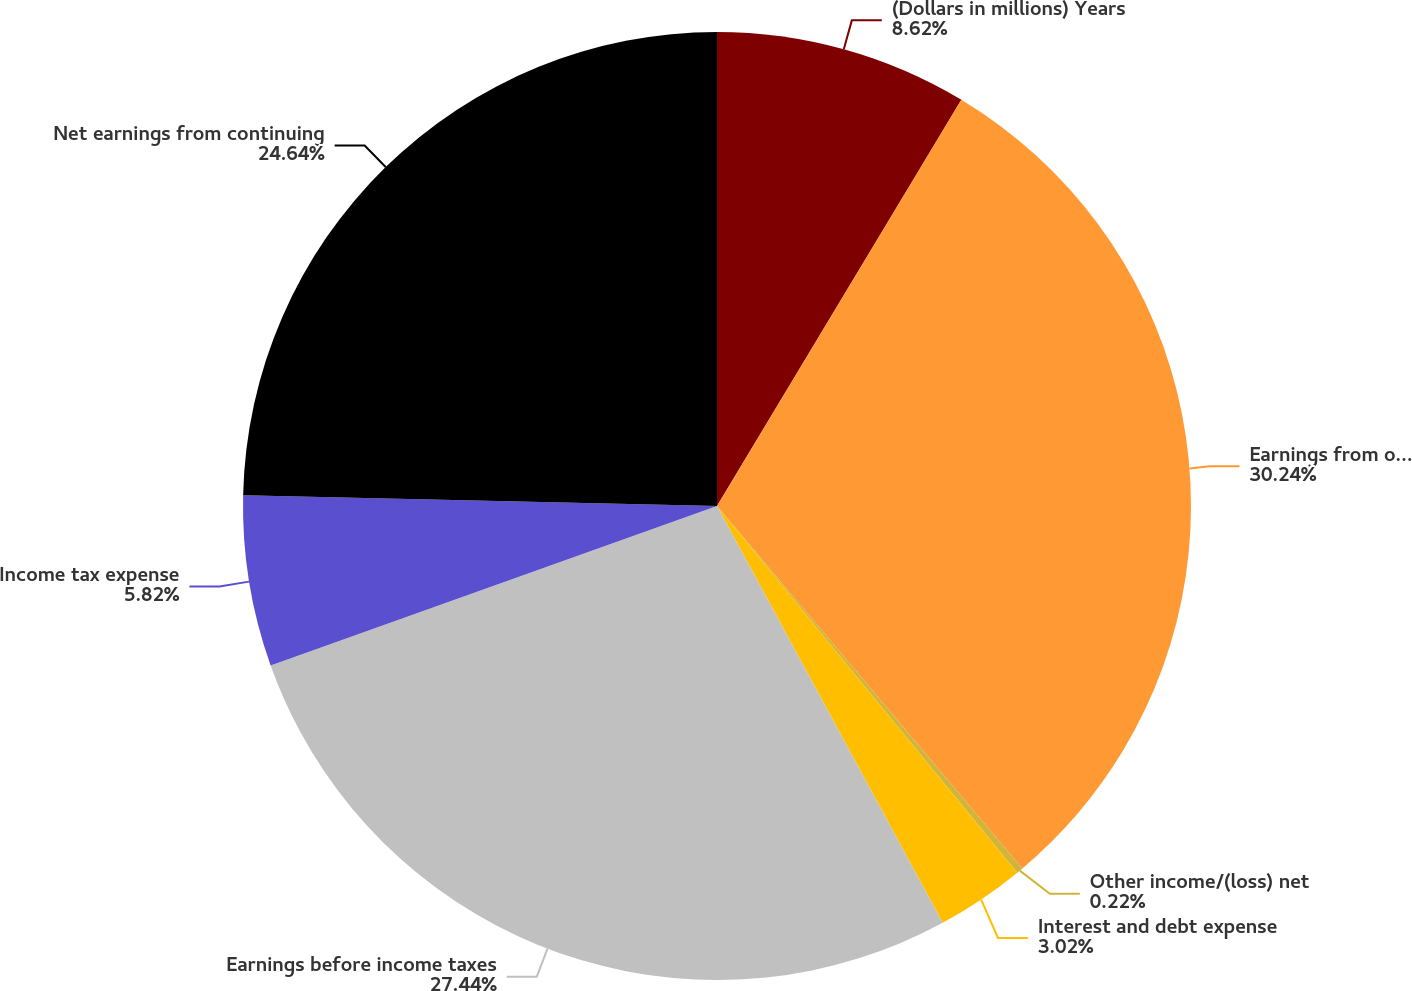Convert chart to OTSL. <chart><loc_0><loc_0><loc_500><loc_500><pie_chart><fcel>(Dollars in millions) Years<fcel>Earnings from operations<fcel>Other income/(loss) net<fcel>Interest and debt expense<fcel>Earnings before income taxes<fcel>Income tax expense<fcel>Net earnings from continuing<nl><fcel>8.62%<fcel>30.24%<fcel>0.22%<fcel>3.02%<fcel>27.44%<fcel>5.82%<fcel>24.64%<nl></chart> 